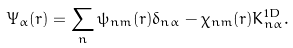Convert formula to latex. <formula><loc_0><loc_0><loc_500><loc_500>\Psi _ { \alpha } ( r ) = \sum _ { n } \psi _ { n m } ( r ) \delta _ { n \alpha } - \chi _ { n m } ( r ) K _ { n \alpha } ^ { 1 D } .</formula> 